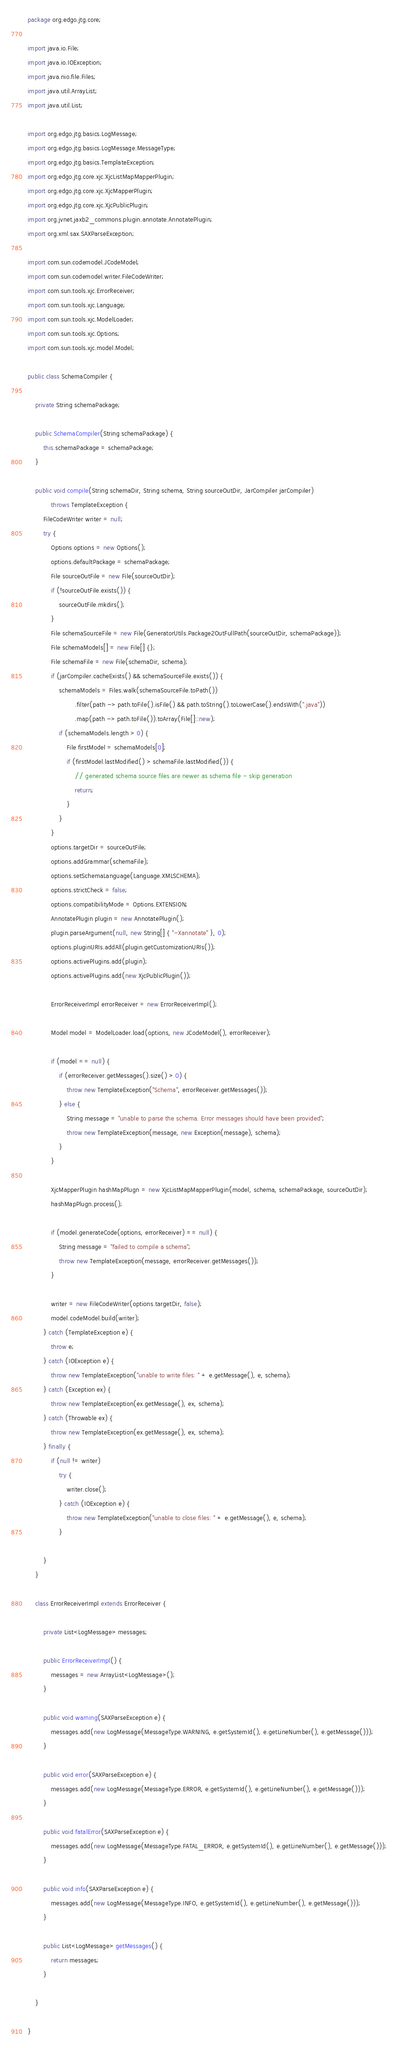Convert code to text. <code><loc_0><loc_0><loc_500><loc_500><_Java_>package org.edgo.jtg.core;

import java.io.File;
import java.io.IOException;
import java.nio.file.Files;
import java.util.ArrayList;
import java.util.List;

import org.edgo.jtg.basics.LogMessage;
import org.edgo.jtg.basics.LogMessage.MessageType;
import org.edgo.jtg.basics.TemplateException;
import org.edgo.jtg.core.xjc.XjcListMapMapperPlugin;
import org.edgo.jtg.core.xjc.XjcMapperPlugin;
import org.edgo.jtg.core.xjc.XjcPublicPlugin;
import org.jvnet.jaxb2_commons.plugin.annotate.AnnotatePlugin;
import org.xml.sax.SAXParseException;

import com.sun.codemodel.JCodeModel;
import com.sun.codemodel.writer.FileCodeWriter;
import com.sun.tools.xjc.ErrorReceiver;
import com.sun.tools.xjc.Language;
import com.sun.tools.xjc.ModelLoader;
import com.sun.tools.xjc.Options;
import com.sun.tools.xjc.model.Model;

public class SchemaCompiler {

	private String schemaPackage;

	public SchemaCompiler(String schemaPackage) {
		this.schemaPackage = schemaPackage;
	}

	public void compile(String schemaDir, String schema, String sourceOutDir, JarCompiler jarCompiler)
			throws TemplateException {
		FileCodeWriter writer = null;
		try {
			Options options = new Options();
			options.defaultPackage = schemaPackage;
			File sourceOutFile = new File(sourceOutDir);
			if (!sourceOutFile.exists()) {
				sourceOutFile.mkdirs();
			}
			File schemaSourceFile = new File(GeneratorUtils.Package2OutFullPath(sourceOutDir, schemaPackage));
			File schemaModels[] = new File[] {};
			File schemaFile = new File(schemaDir, schema);
			if (jarCompiler.cacheExists() && schemaSourceFile.exists()) {
				schemaModels = Files.walk(schemaSourceFile.toPath())
						.filter(path -> path.toFile().isFile() && path.toString().toLowerCase().endsWith(".java"))
						.map(path -> path.toFile()).toArray(File[]::new);
				if (schemaModels.length > 0) {
					File firstModel = schemaModels[0];
					if (firstModel.lastModified() > schemaFile.lastModified()) {
						// generated schema source files are newer as schema file - skip generation
						return;
					}
				}
			}
			options.targetDir = sourceOutFile;
			options.addGrammar(schemaFile);
			options.setSchemaLanguage(Language.XMLSCHEMA);
			options.strictCheck = false;
			options.compatibilityMode = Options.EXTENSION;
			AnnotatePlugin plugin = new AnnotatePlugin();
			plugin.parseArgument(null, new String[] { "-Xannotate" }, 0);
			options.pluginURIs.addAll(plugin.getCustomizationURIs());
			options.activePlugins.add(plugin);
			options.activePlugins.add(new XjcPublicPlugin());

			ErrorReceiverImpl errorReceiver = new ErrorReceiverImpl();

			Model model = ModelLoader.load(options, new JCodeModel(), errorReceiver);

			if (model == null) {
				if (errorReceiver.getMessages().size() > 0) {
					throw new TemplateException("Schema", errorReceiver.getMessages());
				} else {
					String message = "unable to parse the schema. Error messages should have been provided";
					throw new TemplateException(message, new Exception(message), schema);
				}
			}

			XjcMapperPlugin hashMapPlugn = new XjcListMapMapperPlugin(model, schema, schemaPackage, sourceOutDir);
			hashMapPlugn.process();

			if (model.generateCode(options, errorReceiver) == null) {
				String message = "failed to compile a schema";
				throw new TemplateException(message, errorReceiver.getMessages());
			}

			writer = new FileCodeWriter(options.targetDir, false);
			model.codeModel.build(writer);
		} catch (TemplateException e) {
			throw e;
		} catch (IOException e) {
			throw new TemplateException("unable to write files: " + e.getMessage(), e, schema);
		} catch (Exception ex) {
			throw new TemplateException(ex.getMessage(), ex, schema);
		} catch (Throwable ex) {
			throw new TemplateException(ex.getMessage(), ex, schema);
		} finally {
			if (null != writer)
				try {
					writer.close();
				} catch (IOException e) {
					throw new TemplateException("unable to close files: " + e.getMessage(), e, schema);
				}

		}
	}

	class ErrorReceiverImpl extends ErrorReceiver {

		private List<LogMessage> messages;

		public ErrorReceiverImpl() {
			messages = new ArrayList<LogMessage>();
		}

		public void warning(SAXParseException e) {
			messages.add(new LogMessage(MessageType.WARNING, e.getSystemId(), e.getLineNumber(), e.getMessage()));
		}

		public void error(SAXParseException e) {
			messages.add(new LogMessage(MessageType.ERROR, e.getSystemId(), e.getLineNumber(), e.getMessage()));
		}

		public void fatalError(SAXParseException e) {
			messages.add(new LogMessage(MessageType.FATAL_ERROR, e.getSystemId(), e.getLineNumber(), e.getMessage()));
		}

		public void info(SAXParseException e) {
			messages.add(new LogMessage(MessageType.INFO, e.getSystemId(), e.getLineNumber(), e.getMessage()));
		}

		public List<LogMessage> getMessages() {
			return messages;
		}

	}

}
</code> 